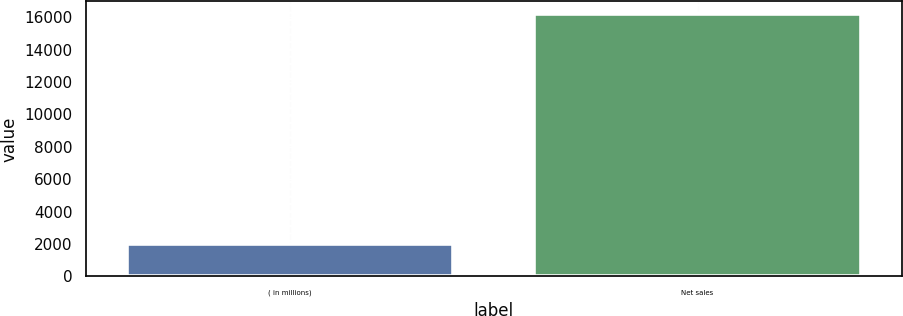<chart> <loc_0><loc_0><loc_500><loc_500><bar_chart><fcel>( in millions)<fcel>Net sales<nl><fcel>2014<fcel>16175<nl></chart> 